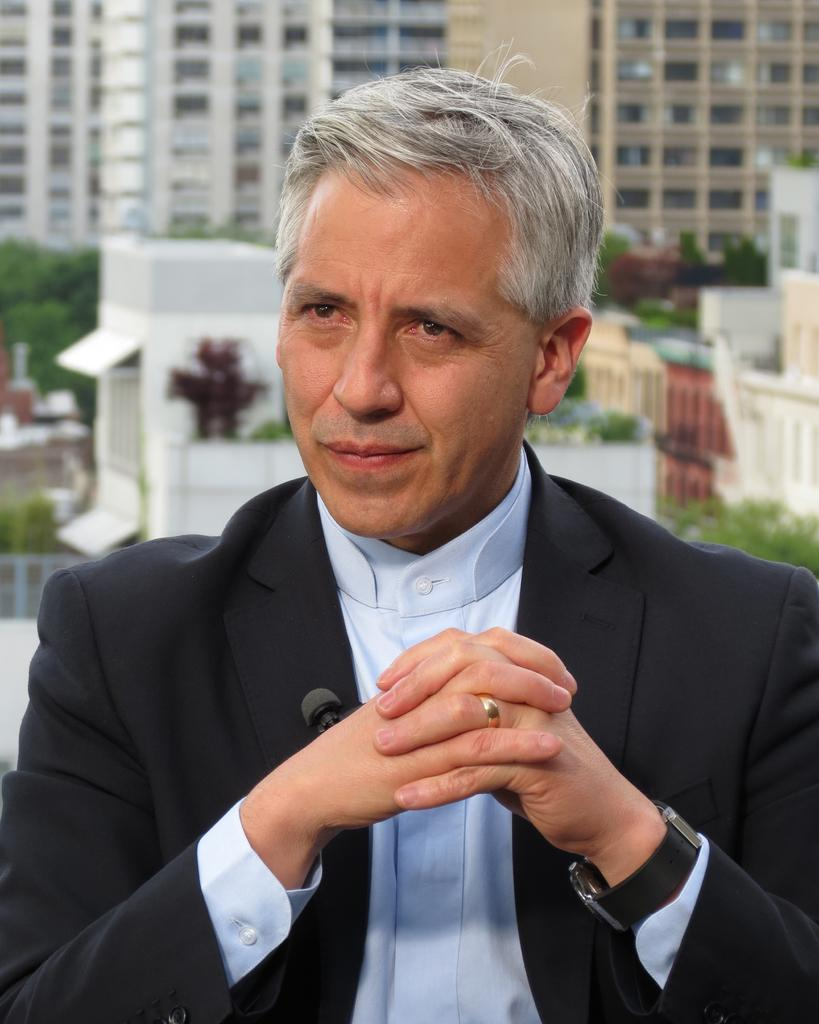Who is present in the image? There is a man in the image. What can be seen in the background of the image? There are buildings, plants, and a group of trees in the background of the image. What month does the man's mind represent in the image? The image does not convey any information about the man's mind or a specific month. 